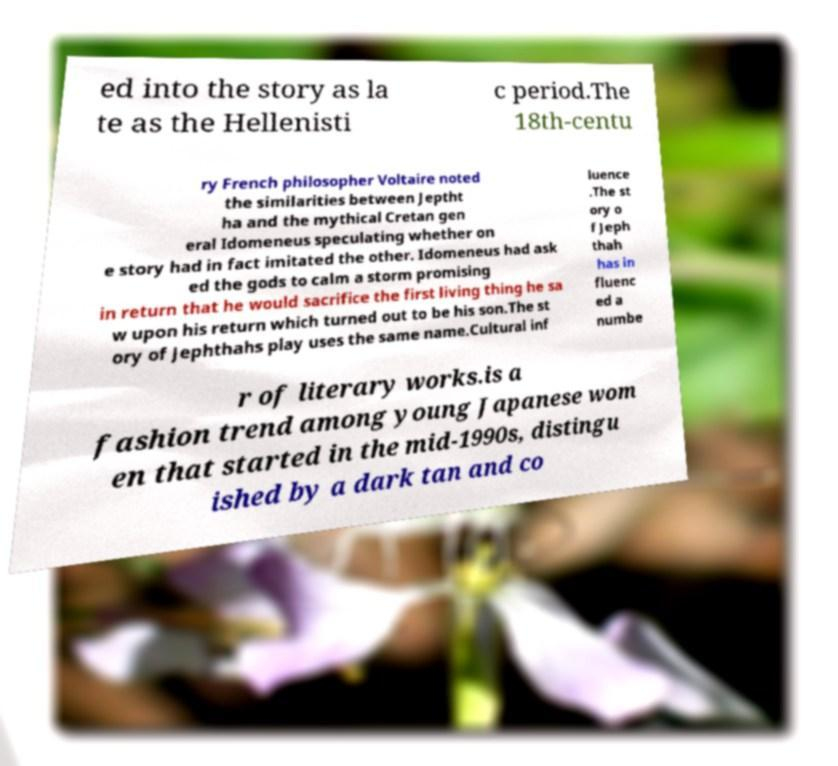I need the written content from this picture converted into text. Can you do that? ed into the story as la te as the Hellenisti c period.The 18th-centu ry French philosopher Voltaire noted the similarities between Jeptht ha and the mythical Cretan gen eral Idomeneus speculating whether on e story had in fact imitated the other. Idomeneus had ask ed the gods to calm a storm promising in return that he would sacrifice the first living thing he sa w upon his return which turned out to be his son.The st ory of Jephthahs play uses the same name.Cultural inf luence .The st ory o f Jeph thah has in fluenc ed a numbe r of literary works.is a fashion trend among young Japanese wom en that started in the mid-1990s, distingu ished by a dark tan and co 